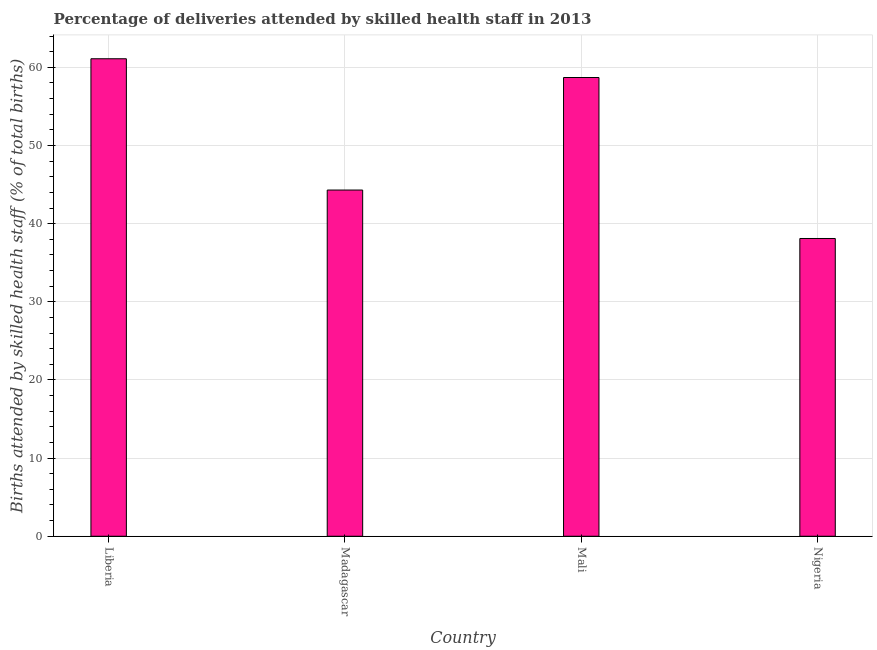What is the title of the graph?
Keep it short and to the point. Percentage of deliveries attended by skilled health staff in 2013. What is the label or title of the X-axis?
Provide a succinct answer. Country. What is the label or title of the Y-axis?
Your answer should be very brief. Births attended by skilled health staff (% of total births). What is the number of births attended by skilled health staff in Madagascar?
Make the answer very short. 44.3. Across all countries, what is the maximum number of births attended by skilled health staff?
Your response must be concise. 61.1. Across all countries, what is the minimum number of births attended by skilled health staff?
Keep it short and to the point. 38.1. In which country was the number of births attended by skilled health staff maximum?
Provide a short and direct response. Liberia. In which country was the number of births attended by skilled health staff minimum?
Ensure brevity in your answer.  Nigeria. What is the sum of the number of births attended by skilled health staff?
Your response must be concise. 202.2. What is the average number of births attended by skilled health staff per country?
Provide a succinct answer. 50.55. What is the median number of births attended by skilled health staff?
Provide a short and direct response. 51.5. What is the ratio of the number of births attended by skilled health staff in Madagascar to that in Nigeria?
Offer a very short reply. 1.16. What is the difference between the highest and the second highest number of births attended by skilled health staff?
Your answer should be compact. 2.4. What is the difference between the highest and the lowest number of births attended by skilled health staff?
Provide a short and direct response. 23. How many bars are there?
Your answer should be compact. 4. Are all the bars in the graph horizontal?
Your answer should be very brief. No. How many countries are there in the graph?
Give a very brief answer. 4. What is the Births attended by skilled health staff (% of total births) in Liberia?
Provide a short and direct response. 61.1. What is the Births attended by skilled health staff (% of total births) of Madagascar?
Keep it short and to the point. 44.3. What is the Births attended by skilled health staff (% of total births) of Mali?
Offer a very short reply. 58.7. What is the Births attended by skilled health staff (% of total births) in Nigeria?
Offer a very short reply. 38.1. What is the difference between the Births attended by skilled health staff (% of total births) in Liberia and Madagascar?
Give a very brief answer. 16.8. What is the difference between the Births attended by skilled health staff (% of total births) in Liberia and Nigeria?
Make the answer very short. 23. What is the difference between the Births attended by skilled health staff (% of total births) in Madagascar and Mali?
Your response must be concise. -14.4. What is the difference between the Births attended by skilled health staff (% of total births) in Mali and Nigeria?
Ensure brevity in your answer.  20.6. What is the ratio of the Births attended by skilled health staff (% of total births) in Liberia to that in Madagascar?
Keep it short and to the point. 1.38. What is the ratio of the Births attended by skilled health staff (% of total births) in Liberia to that in Mali?
Give a very brief answer. 1.04. What is the ratio of the Births attended by skilled health staff (% of total births) in Liberia to that in Nigeria?
Your response must be concise. 1.6. What is the ratio of the Births attended by skilled health staff (% of total births) in Madagascar to that in Mali?
Provide a short and direct response. 0.76. What is the ratio of the Births attended by skilled health staff (% of total births) in Madagascar to that in Nigeria?
Provide a succinct answer. 1.16. What is the ratio of the Births attended by skilled health staff (% of total births) in Mali to that in Nigeria?
Your answer should be very brief. 1.54. 